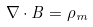<formula> <loc_0><loc_0><loc_500><loc_500>\nabla \cdot B = \rho _ { m }</formula> 